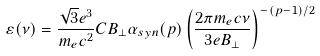Convert formula to latex. <formula><loc_0><loc_0><loc_500><loc_500>\varepsilon ( \nu ) = \frac { \sqrt { 3 } e ^ { 3 } } { m _ { e } c ^ { 2 } } C B _ { \perp } \alpha _ { s y n } ( p ) \left ( \frac { 2 \pi m _ { e } c \nu } { 3 e B _ { \perp } } \right ) ^ { - ( p - 1 ) / 2 }</formula> 